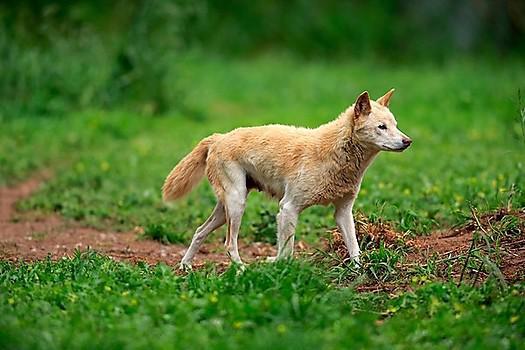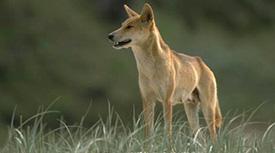The first image is the image on the left, the second image is the image on the right. For the images displayed, is the sentence "A brown dog with large pointy ears is looking directly forward." factually correct? Answer yes or no. No. The first image is the image on the left, the second image is the image on the right. For the images displayed, is the sentence "The combined images include at least two dingo pups and at least one adult dingo." factually correct? Answer yes or no. No. 